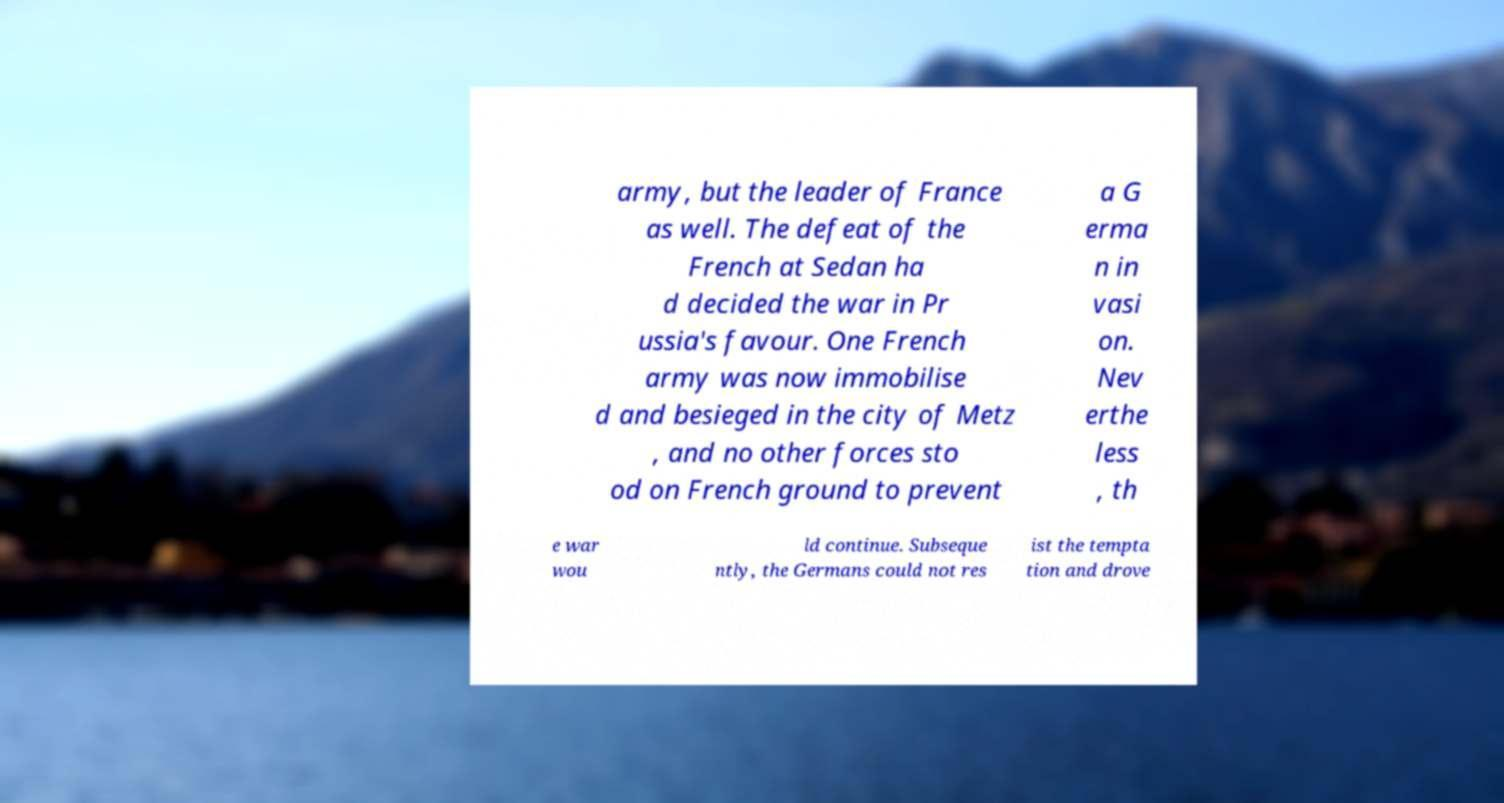I need the written content from this picture converted into text. Can you do that? army, but the leader of France as well. The defeat of the French at Sedan ha d decided the war in Pr ussia's favour. One French army was now immobilise d and besieged in the city of Metz , and no other forces sto od on French ground to prevent a G erma n in vasi on. Nev erthe less , th e war wou ld continue. Subseque ntly, the Germans could not res ist the tempta tion and drove 